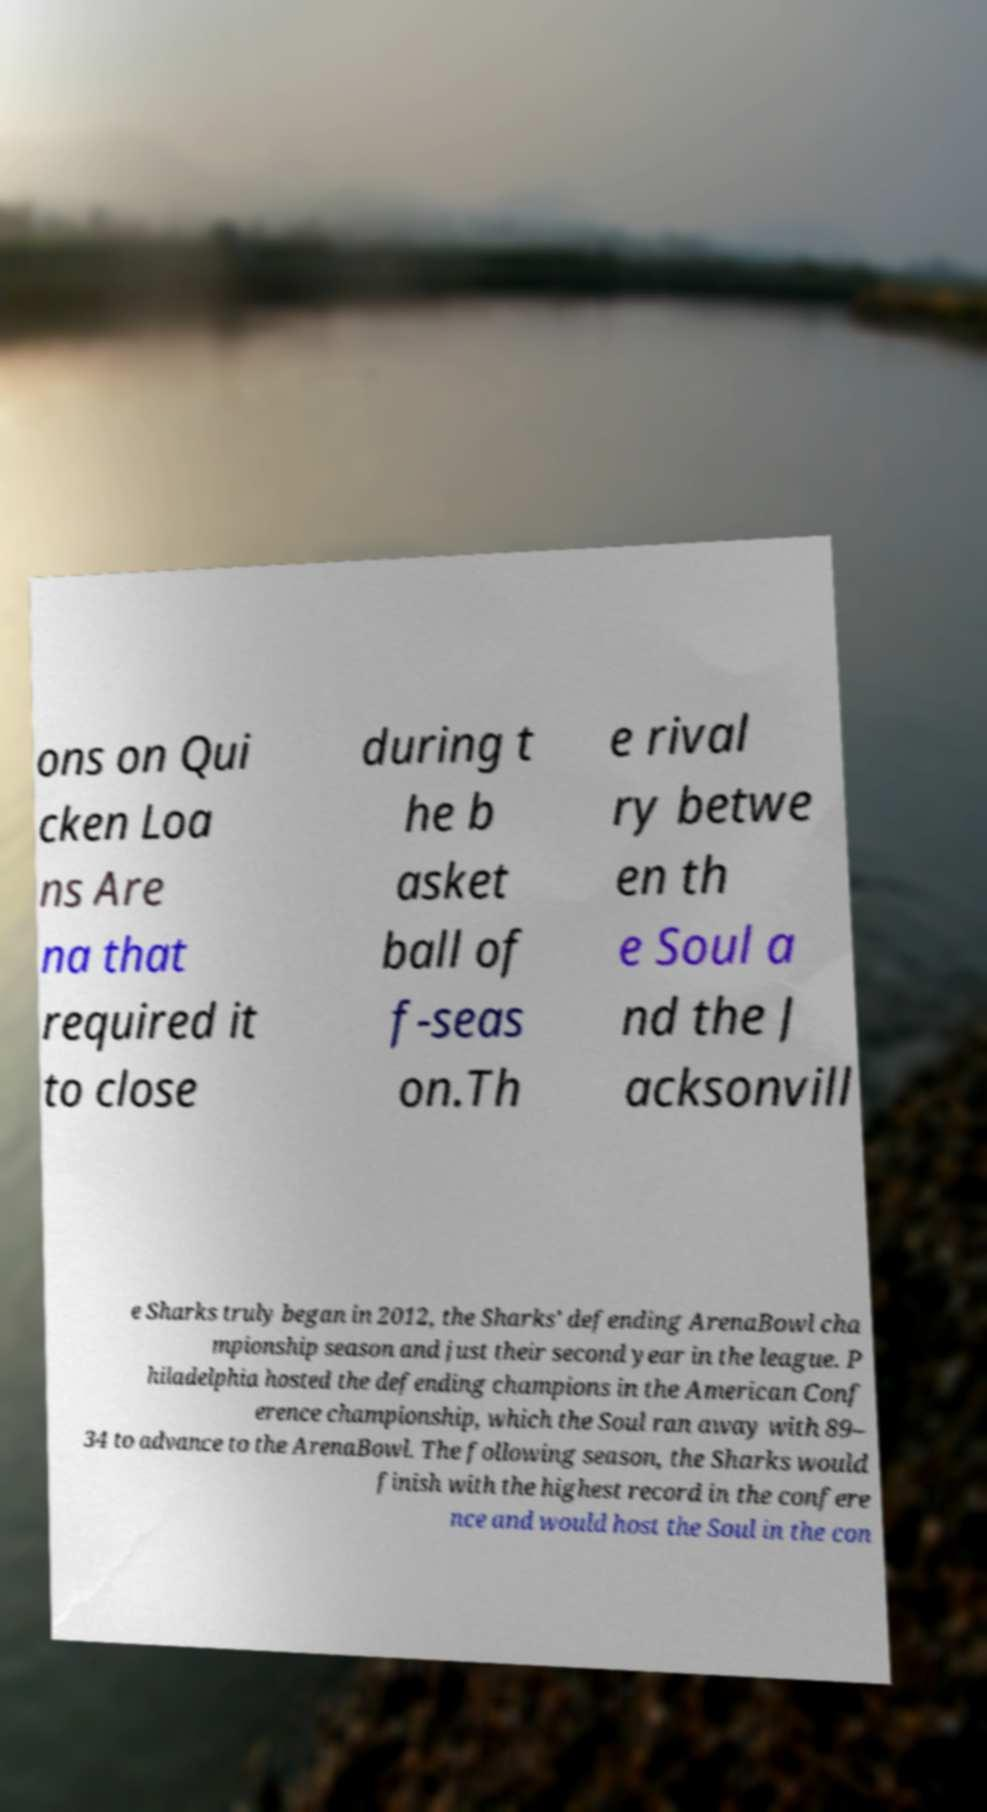Can you accurately transcribe the text from the provided image for me? ons on Qui cken Loa ns Are na that required it to close during t he b asket ball of f-seas on.Th e rival ry betwe en th e Soul a nd the J acksonvill e Sharks truly began in 2012, the Sharks' defending ArenaBowl cha mpionship season and just their second year in the league. P hiladelphia hosted the defending champions in the American Conf erence championship, which the Soul ran away with 89– 34 to advance to the ArenaBowl. The following season, the Sharks would finish with the highest record in the confere nce and would host the Soul in the con 